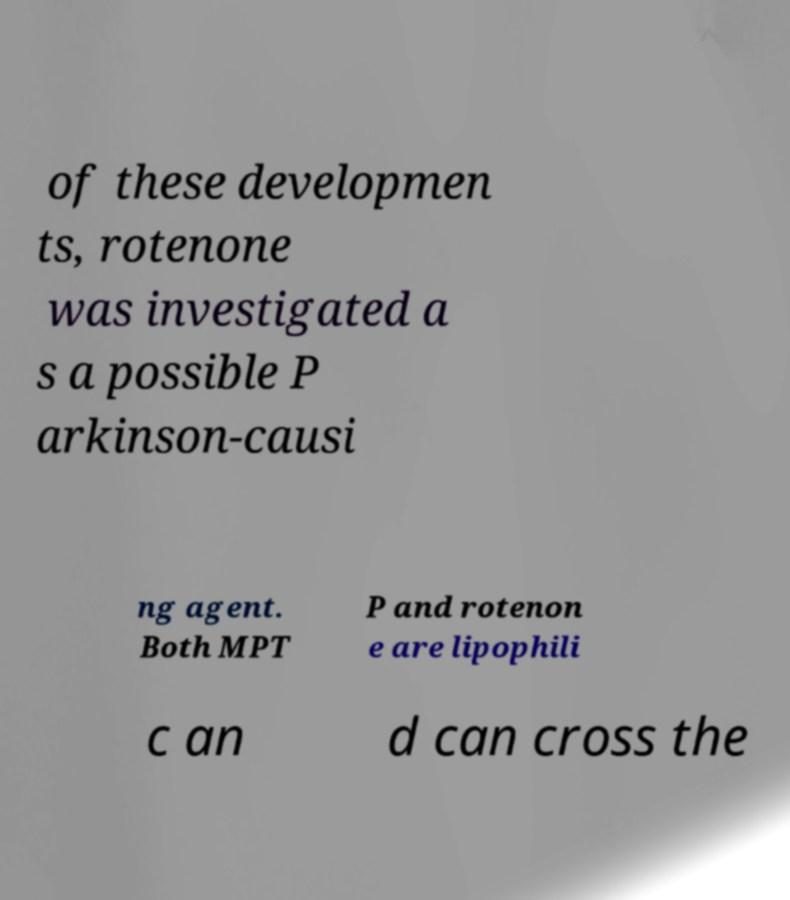What messages or text are displayed in this image? I need them in a readable, typed format. of these developmen ts, rotenone was investigated a s a possible P arkinson-causi ng agent. Both MPT P and rotenon e are lipophili c an d can cross the 